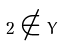Convert formula to latex. <formula><loc_0><loc_0><loc_500><loc_500>2 \notin Y</formula> 